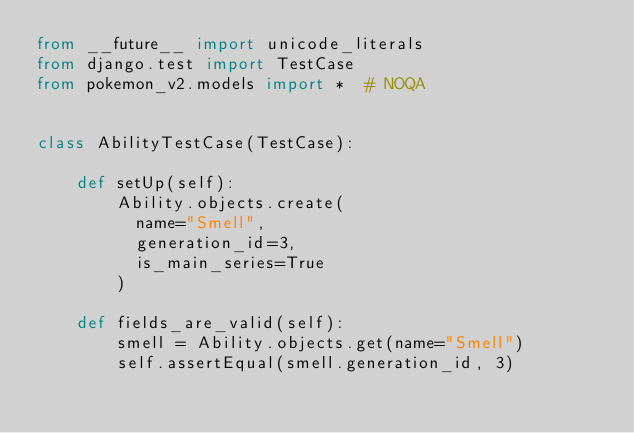Convert code to text. <code><loc_0><loc_0><loc_500><loc_500><_Python_>from __future__ import unicode_literals
from django.test import TestCase
from pokemon_v2.models import *  # NOQA


class AbilityTestCase(TestCase):

    def setUp(self):
        Ability.objects.create(
          name="Smell",
          generation_id=3,
          is_main_series=True
        )

    def fields_are_valid(self):
        smell = Ability.objects.get(name="Smell")
        self.assertEqual(smell.generation_id, 3)
</code> 